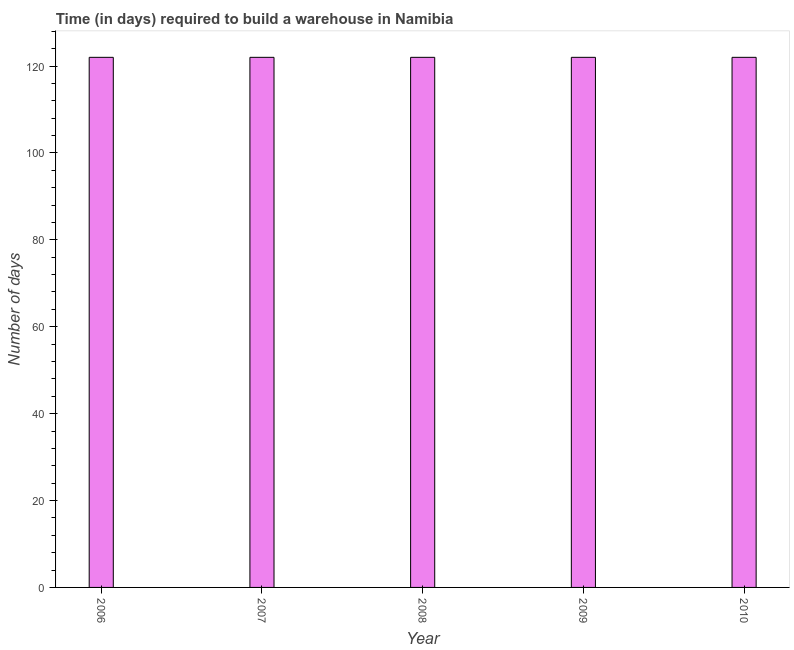Does the graph contain any zero values?
Offer a terse response. No. Does the graph contain grids?
Your response must be concise. No. What is the title of the graph?
Ensure brevity in your answer.  Time (in days) required to build a warehouse in Namibia. What is the label or title of the X-axis?
Offer a very short reply. Year. What is the label or title of the Y-axis?
Your answer should be very brief. Number of days. What is the time required to build a warehouse in 2007?
Keep it short and to the point. 122. Across all years, what is the maximum time required to build a warehouse?
Your answer should be very brief. 122. Across all years, what is the minimum time required to build a warehouse?
Give a very brief answer. 122. What is the sum of the time required to build a warehouse?
Your response must be concise. 610. What is the difference between the time required to build a warehouse in 2008 and 2009?
Your answer should be compact. 0. What is the average time required to build a warehouse per year?
Your answer should be very brief. 122. What is the median time required to build a warehouse?
Make the answer very short. 122. In how many years, is the time required to build a warehouse greater than 84 days?
Provide a succinct answer. 5. Do a majority of the years between 2006 and 2007 (inclusive) have time required to build a warehouse greater than 124 days?
Your response must be concise. No. What is the ratio of the time required to build a warehouse in 2007 to that in 2009?
Your answer should be compact. 1. Is the time required to build a warehouse in 2007 less than that in 2008?
Offer a very short reply. No. What is the difference between the highest and the second highest time required to build a warehouse?
Ensure brevity in your answer.  0. What is the difference between the highest and the lowest time required to build a warehouse?
Offer a very short reply. 0. In how many years, is the time required to build a warehouse greater than the average time required to build a warehouse taken over all years?
Give a very brief answer. 0. Are all the bars in the graph horizontal?
Your answer should be very brief. No. Are the values on the major ticks of Y-axis written in scientific E-notation?
Ensure brevity in your answer.  No. What is the Number of days in 2006?
Give a very brief answer. 122. What is the Number of days in 2007?
Offer a terse response. 122. What is the Number of days of 2008?
Keep it short and to the point. 122. What is the Number of days in 2009?
Ensure brevity in your answer.  122. What is the Number of days of 2010?
Provide a succinct answer. 122. What is the difference between the Number of days in 2006 and 2010?
Your answer should be compact. 0. What is the difference between the Number of days in 2007 and 2008?
Offer a terse response. 0. What is the difference between the Number of days in 2007 and 2009?
Keep it short and to the point. 0. What is the difference between the Number of days in 2007 and 2010?
Ensure brevity in your answer.  0. What is the difference between the Number of days in 2009 and 2010?
Provide a succinct answer. 0. What is the ratio of the Number of days in 2006 to that in 2007?
Make the answer very short. 1. What is the ratio of the Number of days in 2006 to that in 2008?
Your answer should be very brief. 1. What is the ratio of the Number of days in 2006 to that in 2009?
Provide a short and direct response. 1. What is the ratio of the Number of days in 2006 to that in 2010?
Offer a very short reply. 1. What is the ratio of the Number of days in 2007 to that in 2009?
Provide a succinct answer. 1. What is the ratio of the Number of days in 2008 to that in 2010?
Offer a very short reply. 1. What is the ratio of the Number of days in 2009 to that in 2010?
Provide a short and direct response. 1. 